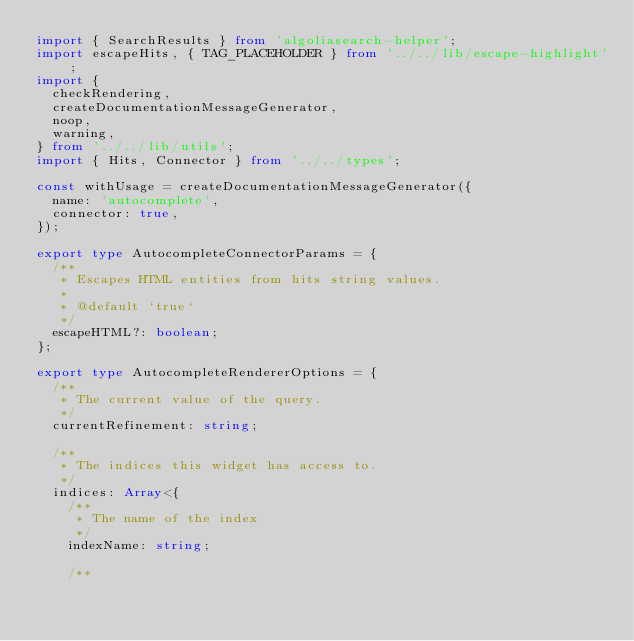<code> <loc_0><loc_0><loc_500><loc_500><_TypeScript_>import { SearchResults } from 'algoliasearch-helper';
import escapeHits, { TAG_PLACEHOLDER } from '../../lib/escape-highlight';
import {
  checkRendering,
  createDocumentationMessageGenerator,
  noop,
  warning,
} from '../../lib/utils';
import { Hits, Connector } from '../../types';

const withUsage = createDocumentationMessageGenerator({
  name: 'autocomplete',
  connector: true,
});

export type AutocompleteConnectorParams = {
  /**
   * Escapes HTML entities from hits string values.
   *
   * @default `true`
   */
  escapeHTML?: boolean;
};

export type AutocompleteRendererOptions = {
  /**
   * The current value of the query.
   */
  currentRefinement: string;

  /**
   * The indices this widget has access to.
   */
  indices: Array<{
    /**
     * The name of the index
     */
    indexName: string;

    /**</code> 